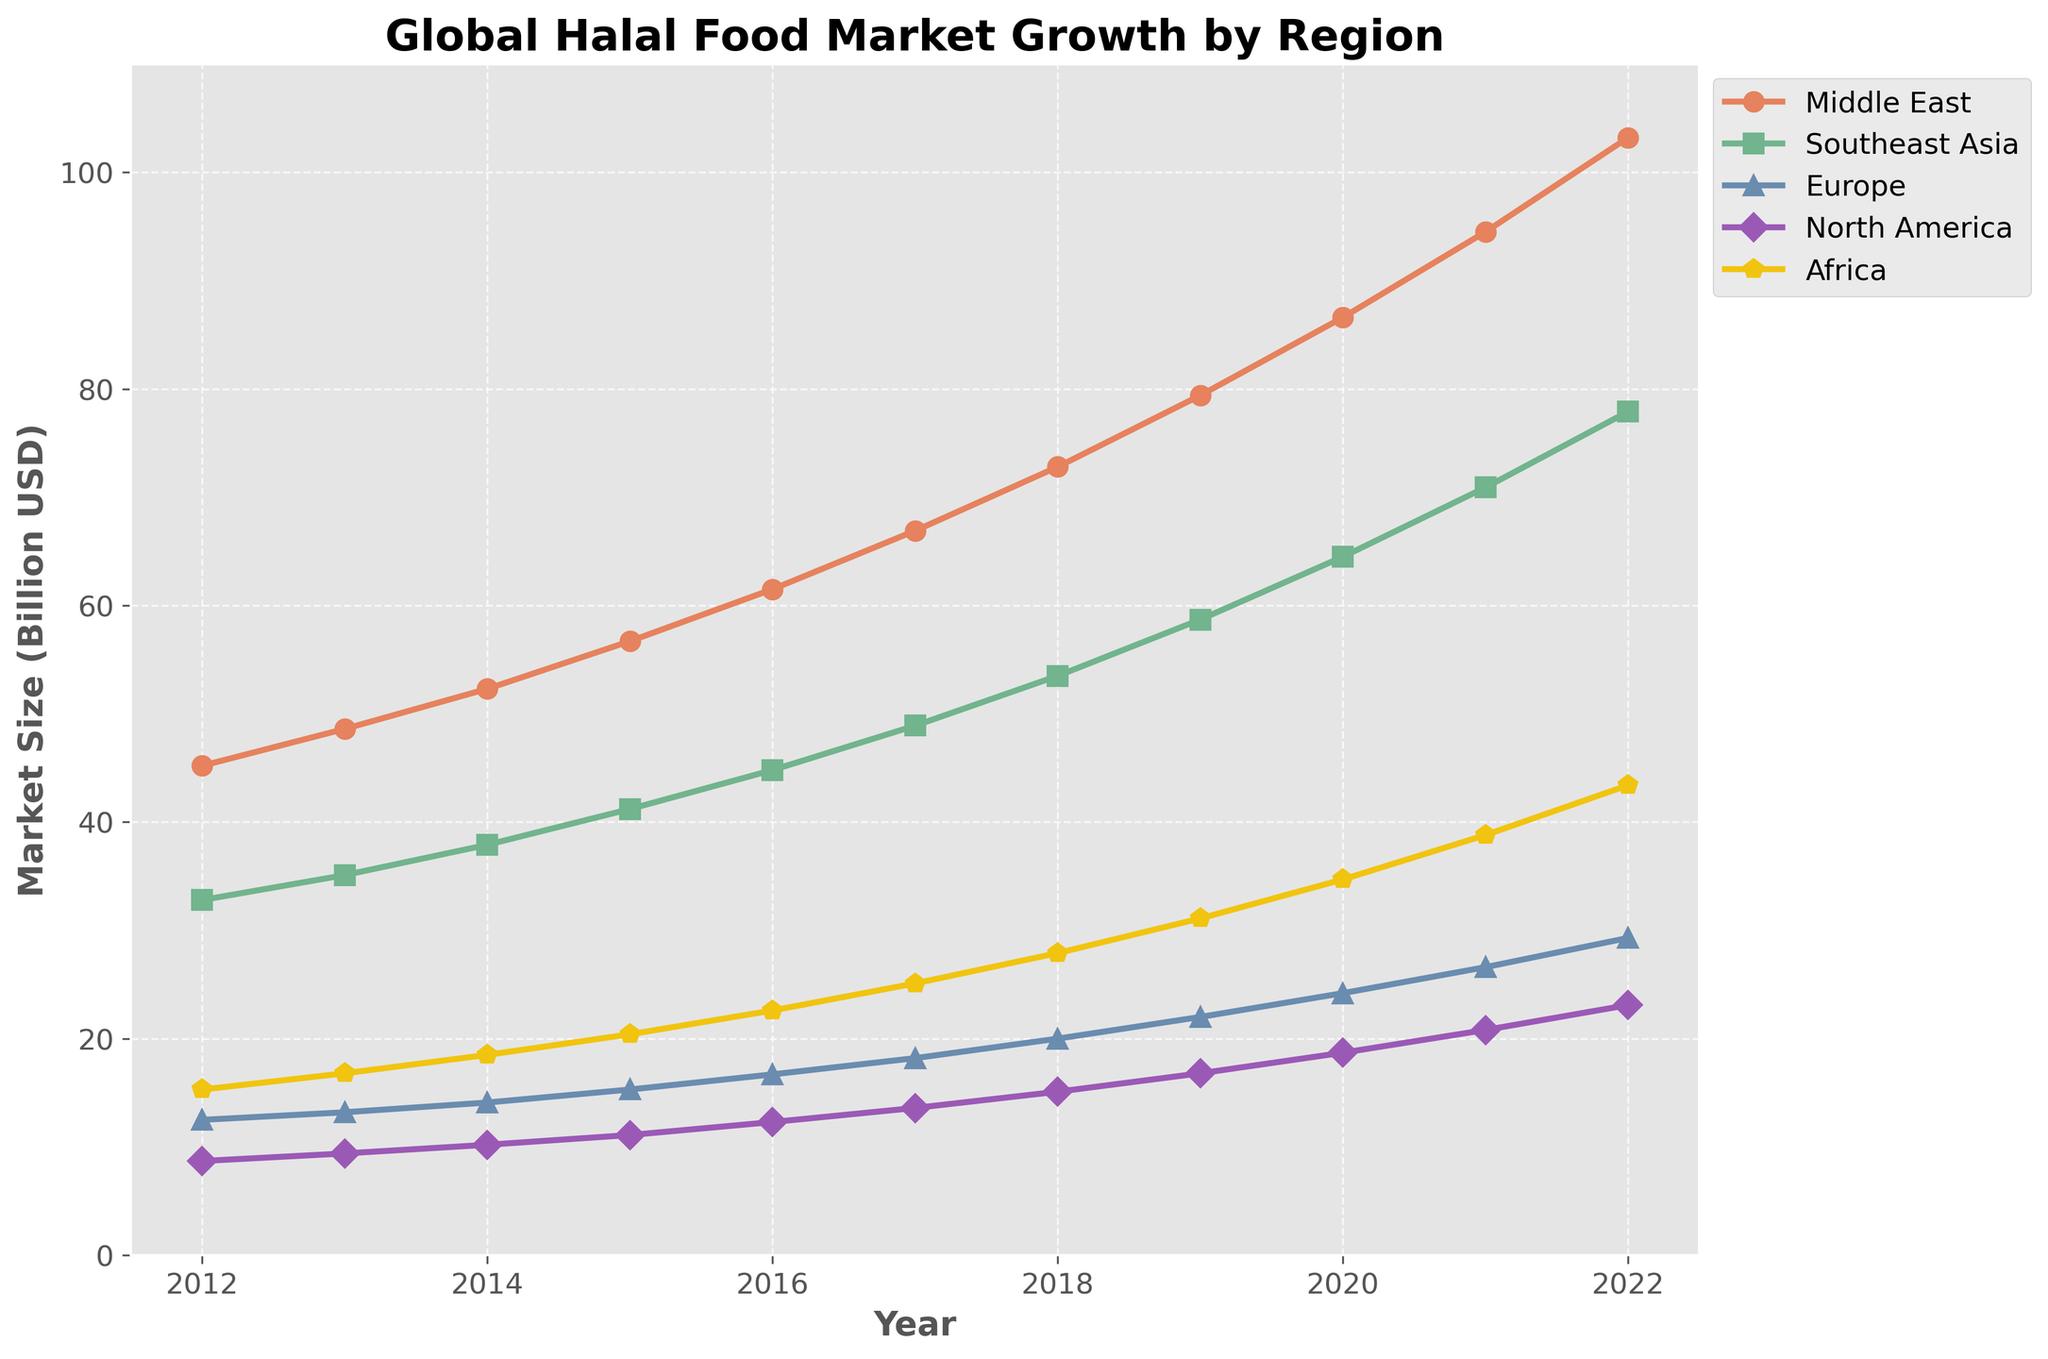What region shows the highest growth in market size from 2012 to 2022? The Middle East starts at 45.2 billion USD in 2012 and grows to 103.2 billion USD in 2022, which is an increase of 58 billion USD. This is the highest among all regions.
Answer: Middle East Which region has the lowest market size in 2012, and what is this value? By looking at the starting values for 2012, North America has the lowest market size at 8.7 billion USD.
Answer: North America, 8.7 billion USD In 2020, how much larger is the market size of the Middle East compared to Europe? In 2020, the Middle East has a market size of 86.6 billion USD, and Europe has 24.2 billion USD. The difference is 86.6 - 24.2 = 62.4 billion USD.
Answer: 62.4 billion USD Which region crosses the 50 billion USD mark first, and in what year? Southeast Asia crosses the 50 billion USD mark in 2018, with a value of 53.5 billion USD.
Answer: Southeast Asia, 2018 What is the average market size of Africa from 2012 to 2022? The values for Africa from 2012 to 2022 are: 15.3, 16.8, 18.5, 20.4, 22.6, 25.1, 27.9, 31.1, 34.7, 38.8, 43.4. Sum these values to get 294.6. There are 11 years, so the average is 294.6 / 11 ≈ 26.78 billion USD.
Answer: 26.78 billion USD Comparing 2015 and 2018, in which year does North America have a higher market size, and by how much? In 2015, North America's market size is 11.1 billion USD, and in 2018 it is 15.1 billion USD. Difference is 15.1 - 11.1 = 4 billion USD.
Answer: 2018, 4 billion USD What is the total market size for all regions in 2022? Summing the 2022 values: 103.2 (Middle East) + 77.9 (Southeast Asia) + 29.3 (Europe) + 23.1 (North America) + 43.4 (Africa) = 276.9 billion USD.
Answer: 276.9 billion USD Which region shows the most consistent growth over the decade? Observing the lines, Africa shows the most consistent growth because its line appears to increase steadily without dramatic fluctuations.
Answer: Africa 